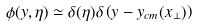<formula> <loc_0><loc_0><loc_500><loc_500>\phi ( y , \eta ) \simeq \delta ( \eta ) \delta \left ( y - y _ { c m } ( x _ { \perp } ) \right )</formula> 